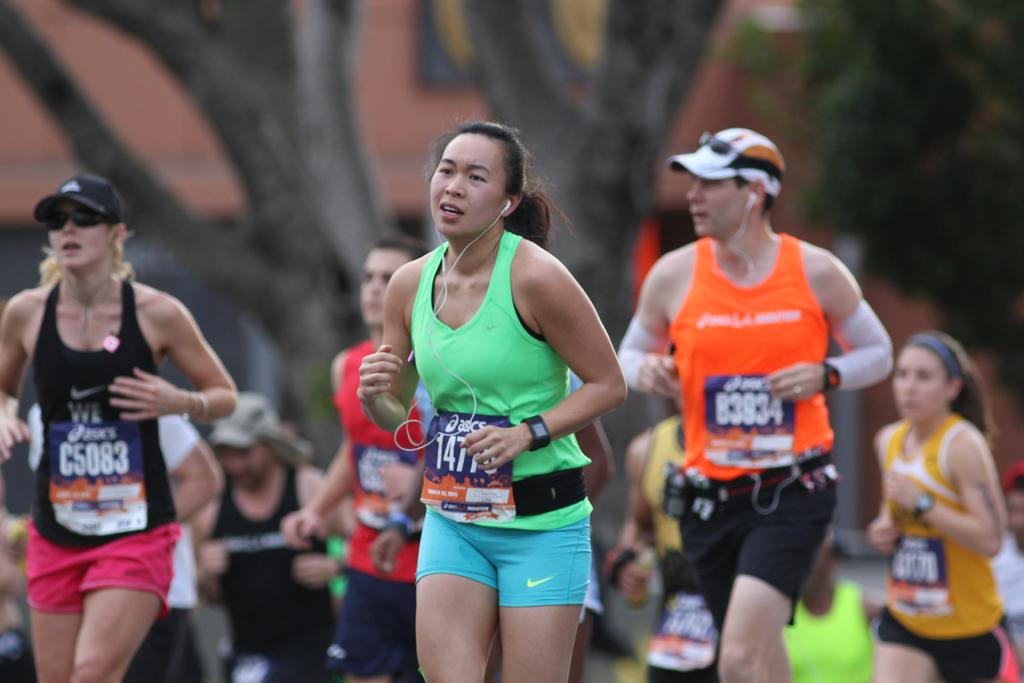<image>
Provide a brief description of the given image. A group of runners are wearing numbered tags and one of them says B3934. 